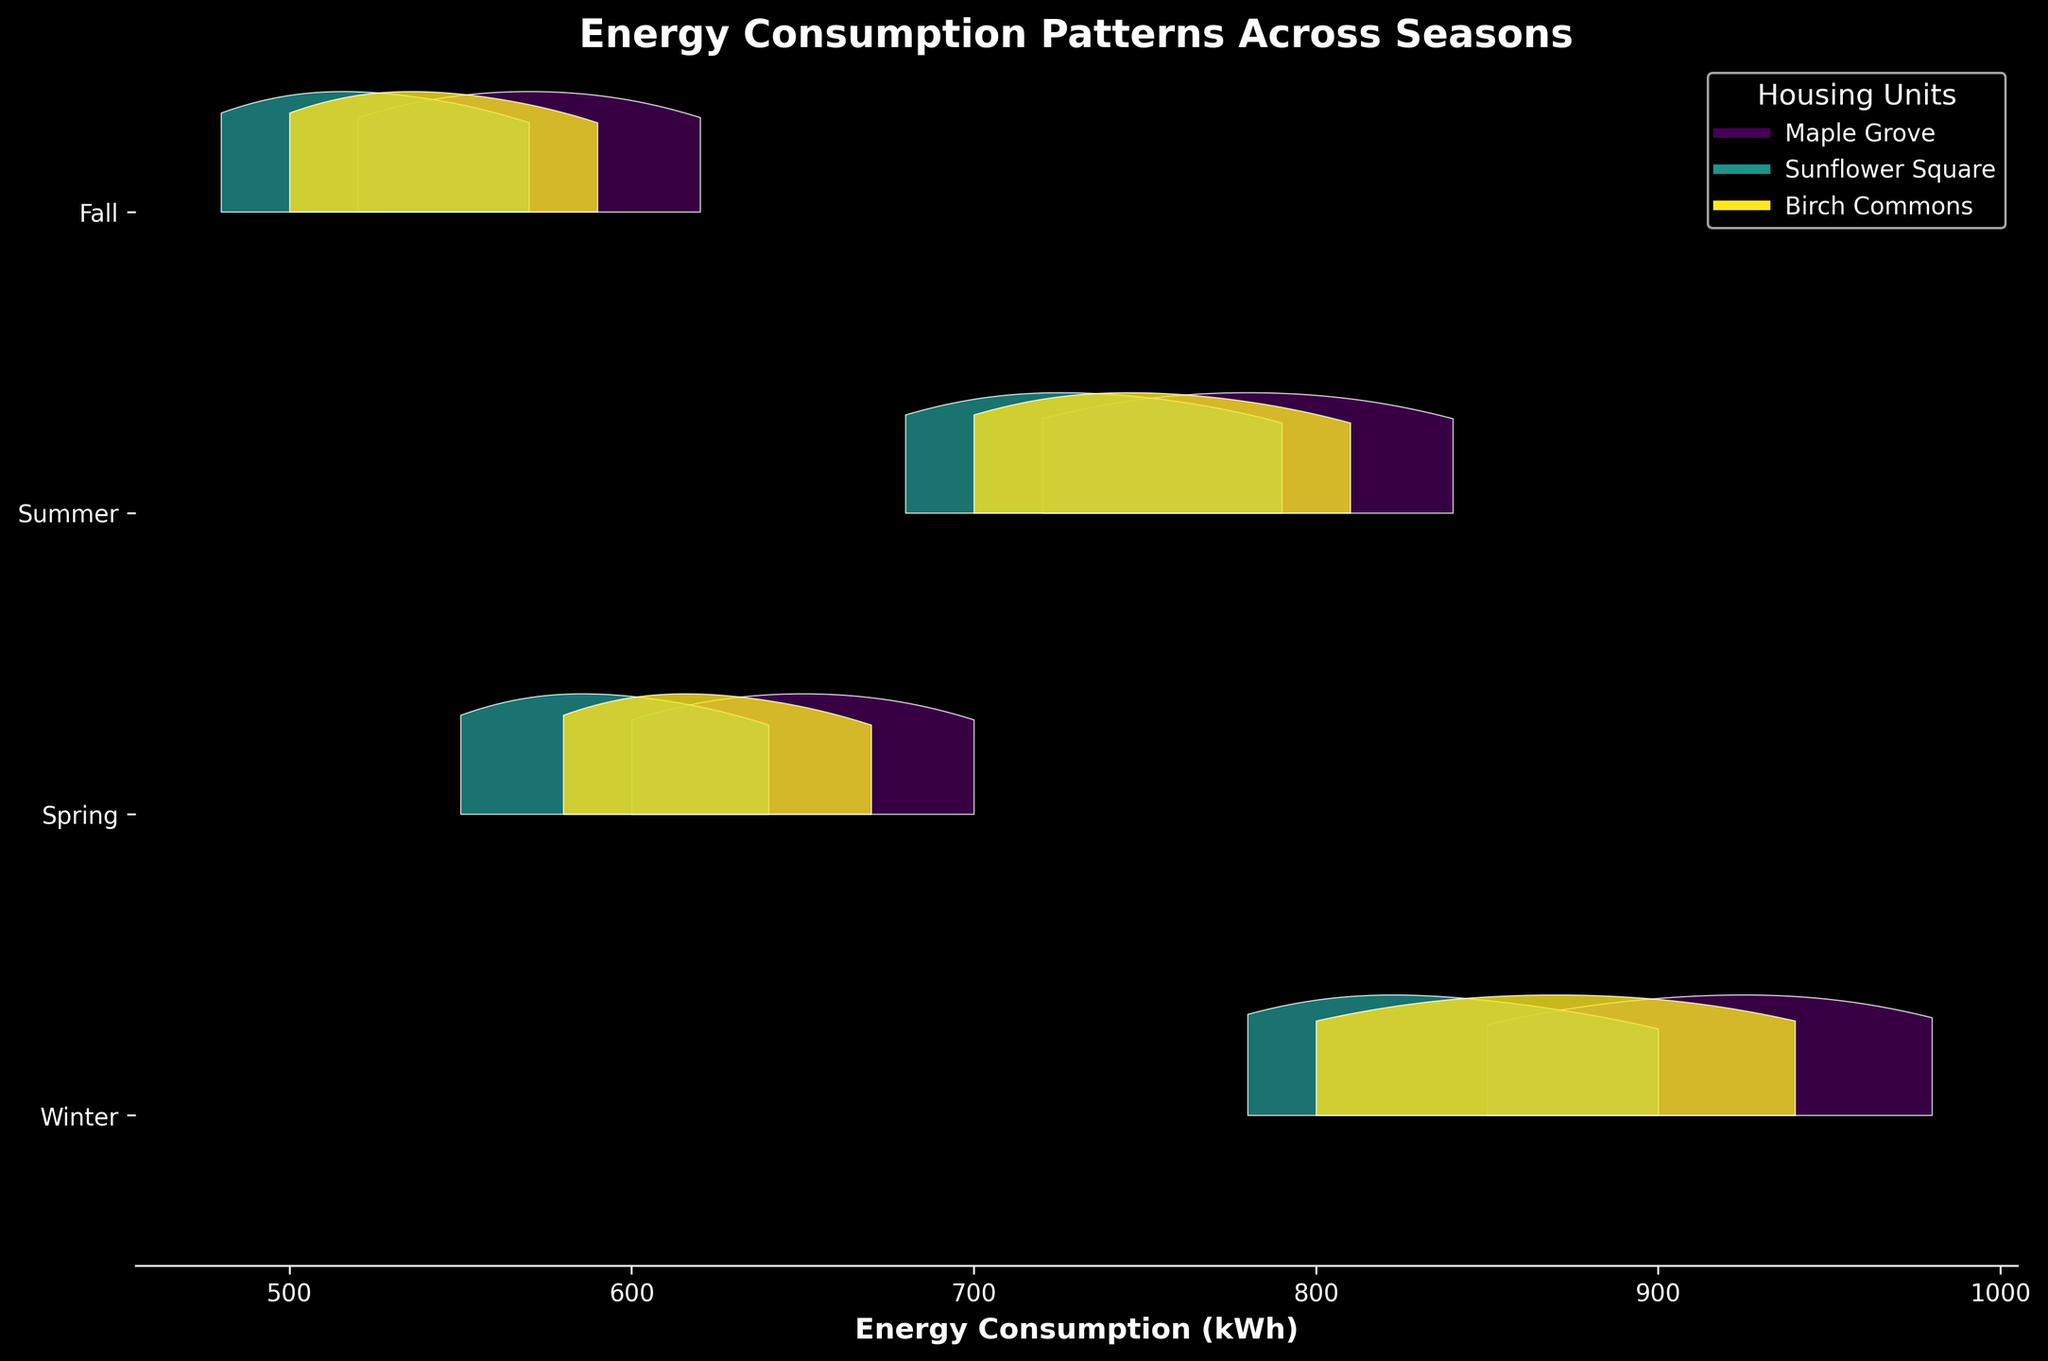Which season shows the highest peak in energy consumption for Maple Grove? To find the highest peak in energy consumption for Maple Grove, observe the four ridges associated with Maple Grove in each season. The highest peak y-value corresponds to Winter because its peak is higher than the ones in Spring, Summer, and Fall.
Answer: Winter What is the title of the plot? The title is displayed at the top of the plot.
Answer: Energy Consumption Patterns Across Seasons Which unit's energy consumption pattern appears more spread out in Summer? Look at the width of the ridges for each unit in Summer. For Birch Commons, the ridge appears wider, indicating a more spread-out energy consumption pattern.
Answer: Birch Commons What is the range of energy consumption in Fall for Sunflower Square? Follow the ridge lines for Sunflower Square during Fall and check the x-axis range that it covers. The pattern spans from roughly 480 to 570 kWh.
Answer: 480 to 570 kWh During which season does Sunflower Square have the narrowest energy consumption pattern? The narrowest energy consumption pattern for Sunflower Square is observed where the peak is most concentrated. This appears to be in Winter, as the ridge is the most concentrated and narrowest.
Answer: Winter Compare the peak energy consumption in Spring for Maple Grove and Birch Commons. Which is higher? Look at the peaks of the ridges for Maple Grove and Birch Commons in Spring. The peak for Maple Grove is higher than that of Birch Commons.
Answer: Maple Grove Which season has the broadest range of energy consumption for Birch Commons? Observe the widths of the ridges for Birch Commons across all seasons. The broadest range occurs during Winter, indicated by the widest spread on the x-axis.
Answer: Winter What pattern do you observe in energy consumption for all units from Winter to Fall? Observing the ridges for all units, there's a general trend of decreasing consumption from Winter (highest peaks) to Fall (lowest peaks).
Answer: Decreasing trend How does the energy consumption peak of Summer for Sunflower Square compare to that of Maple Grove? Compare the peak values of the ridges for Sunflower Square and Maple Grove in Summer. The peak for Sunflower Square is slightly lower than that of Maple Grove.
Answer: Slightly lower 